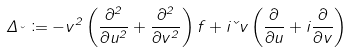<formula> <loc_0><loc_0><loc_500><loc_500>\Delta _ { \kappa } \coloneqq - v ^ { 2 } \left ( \frac { \partial ^ { 2 } } { \partial u ^ { 2 } } + \frac { \partial ^ { 2 } } { \partial v ^ { 2 } } \right ) f + i \kappa v \left ( \frac { \partial } { \partial u } + i \frac { \partial } { \partial v } \right )</formula> 